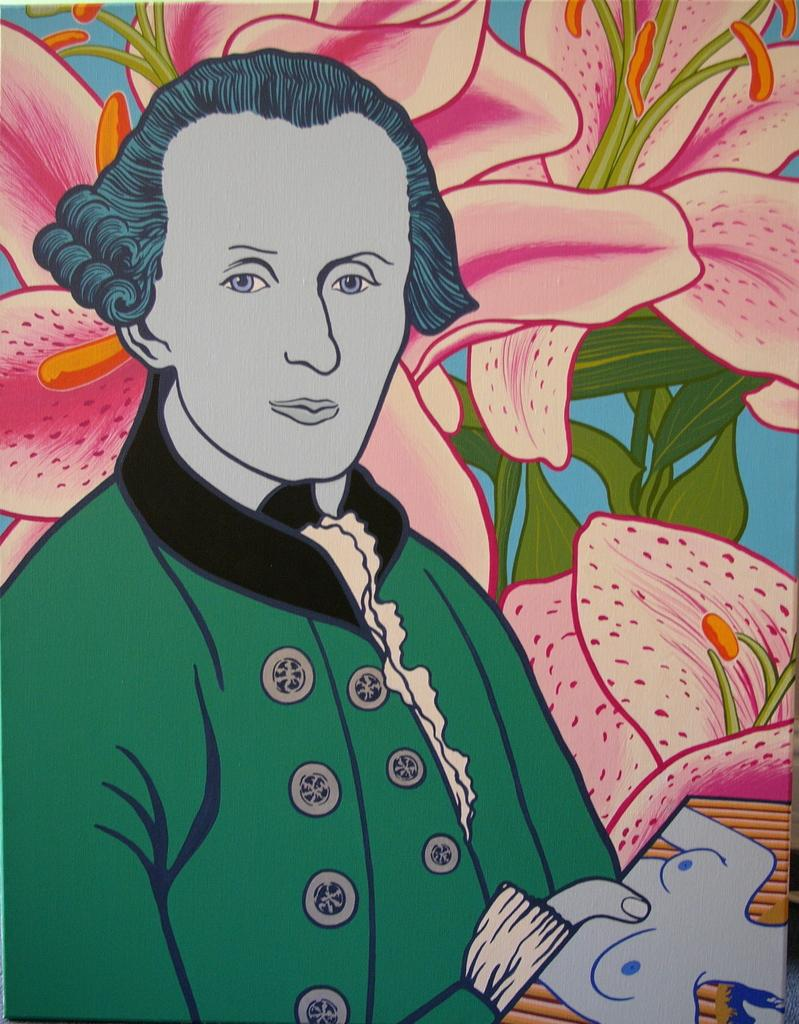What type of object is featured in the image? The image contains an art piece. What is the subject of the art piece? The art piece depicts a person. What other elements are included in the art piece? The art piece includes flowers and leaves. What is the person in the art piece holding? The person in the art piece is holding a picture. What color is the background of the art piece? The background of the art piece is blue. What type of power source is depicted in the art piece? There is no power source depicted in the art piece; it features a person, flowers, leaves, and a picture being held. How many birds are present in the art piece? There are no birds or flocks mentioned in the art piece; it includes a person, flowers, leaves, and a picture being held. 